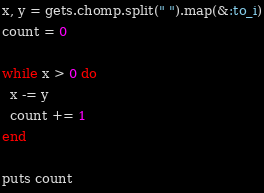<code> <loc_0><loc_0><loc_500><loc_500><_Ruby_>x, y = gets.chomp.split(" ").map(&:to_i)
count = 0

while x > 0 do
  x -= y
  count += 1
end

puts count

</code> 